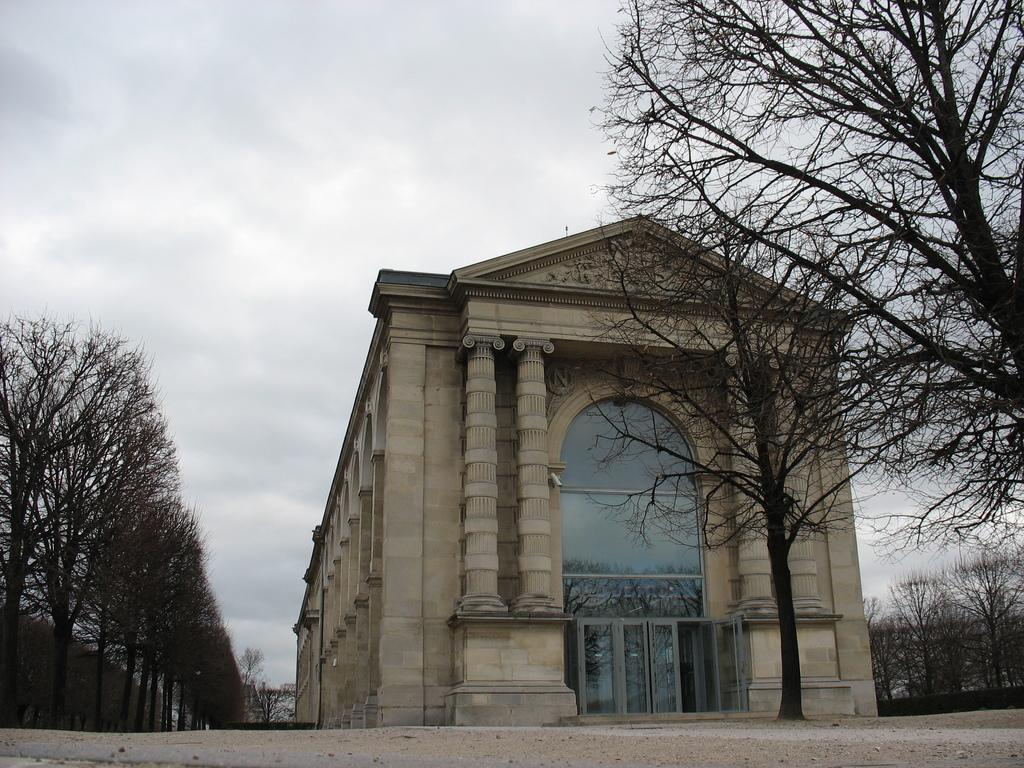What is the main subject in the middle of the image? There is a building in the middle of the image. Are there any other buildings visible in the image? Yes, there are buildings on the right side and the left side of the image. What can be seen at the top of the image? The sky is visible at the top of the image. What type of chain can be seen hanging from the building in the image? There is no chain visible hanging from any building in the image. 